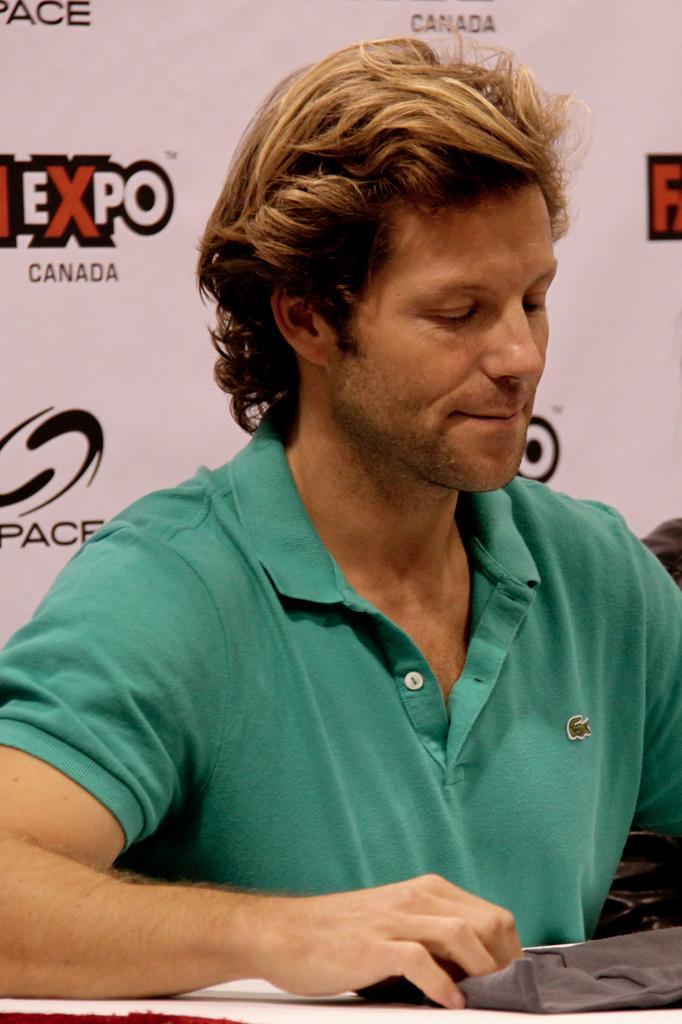Describe this image in one or two sentences. In this image, we can see a person wearing clothes. In the background of the image, we can see some text. 